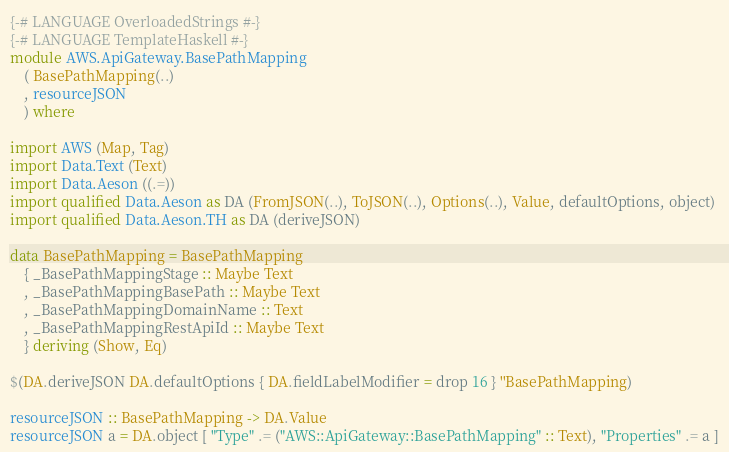Convert code to text. <code><loc_0><loc_0><loc_500><loc_500><_Haskell_>{-# LANGUAGE OverloadedStrings #-}
{-# LANGUAGE TemplateHaskell #-}
module AWS.ApiGateway.BasePathMapping
    ( BasePathMapping(..)
    , resourceJSON
    ) where

import AWS (Map, Tag)
import Data.Text (Text)
import Data.Aeson ((.=))
import qualified Data.Aeson as DA (FromJSON(..), ToJSON(..), Options(..), Value, defaultOptions, object)
import qualified Data.Aeson.TH as DA (deriveJSON)

data BasePathMapping = BasePathMapping
    { _BasePathMappingStage :: Maybe Text
    , _BasePathMappingBasePath :: Maybe Text
    , _BasePathMappingDomainName :: Text
    , _BasePathMappingRestApiId :: Maybe Text
    } deriving (Show, Eq)

$(DA.deriveJSON DA.defaultOptions { DA.fieldLabelModifier = drop 16 } ''BasePathMapping)

resourceJSON :: BasePathMapping -> DA.Value
resourceJSON a = DA.object [ "Type" .= ("AWS::ApiGateway::BasePathMapping" :: Text), "Properties" .= a ]
</code> 